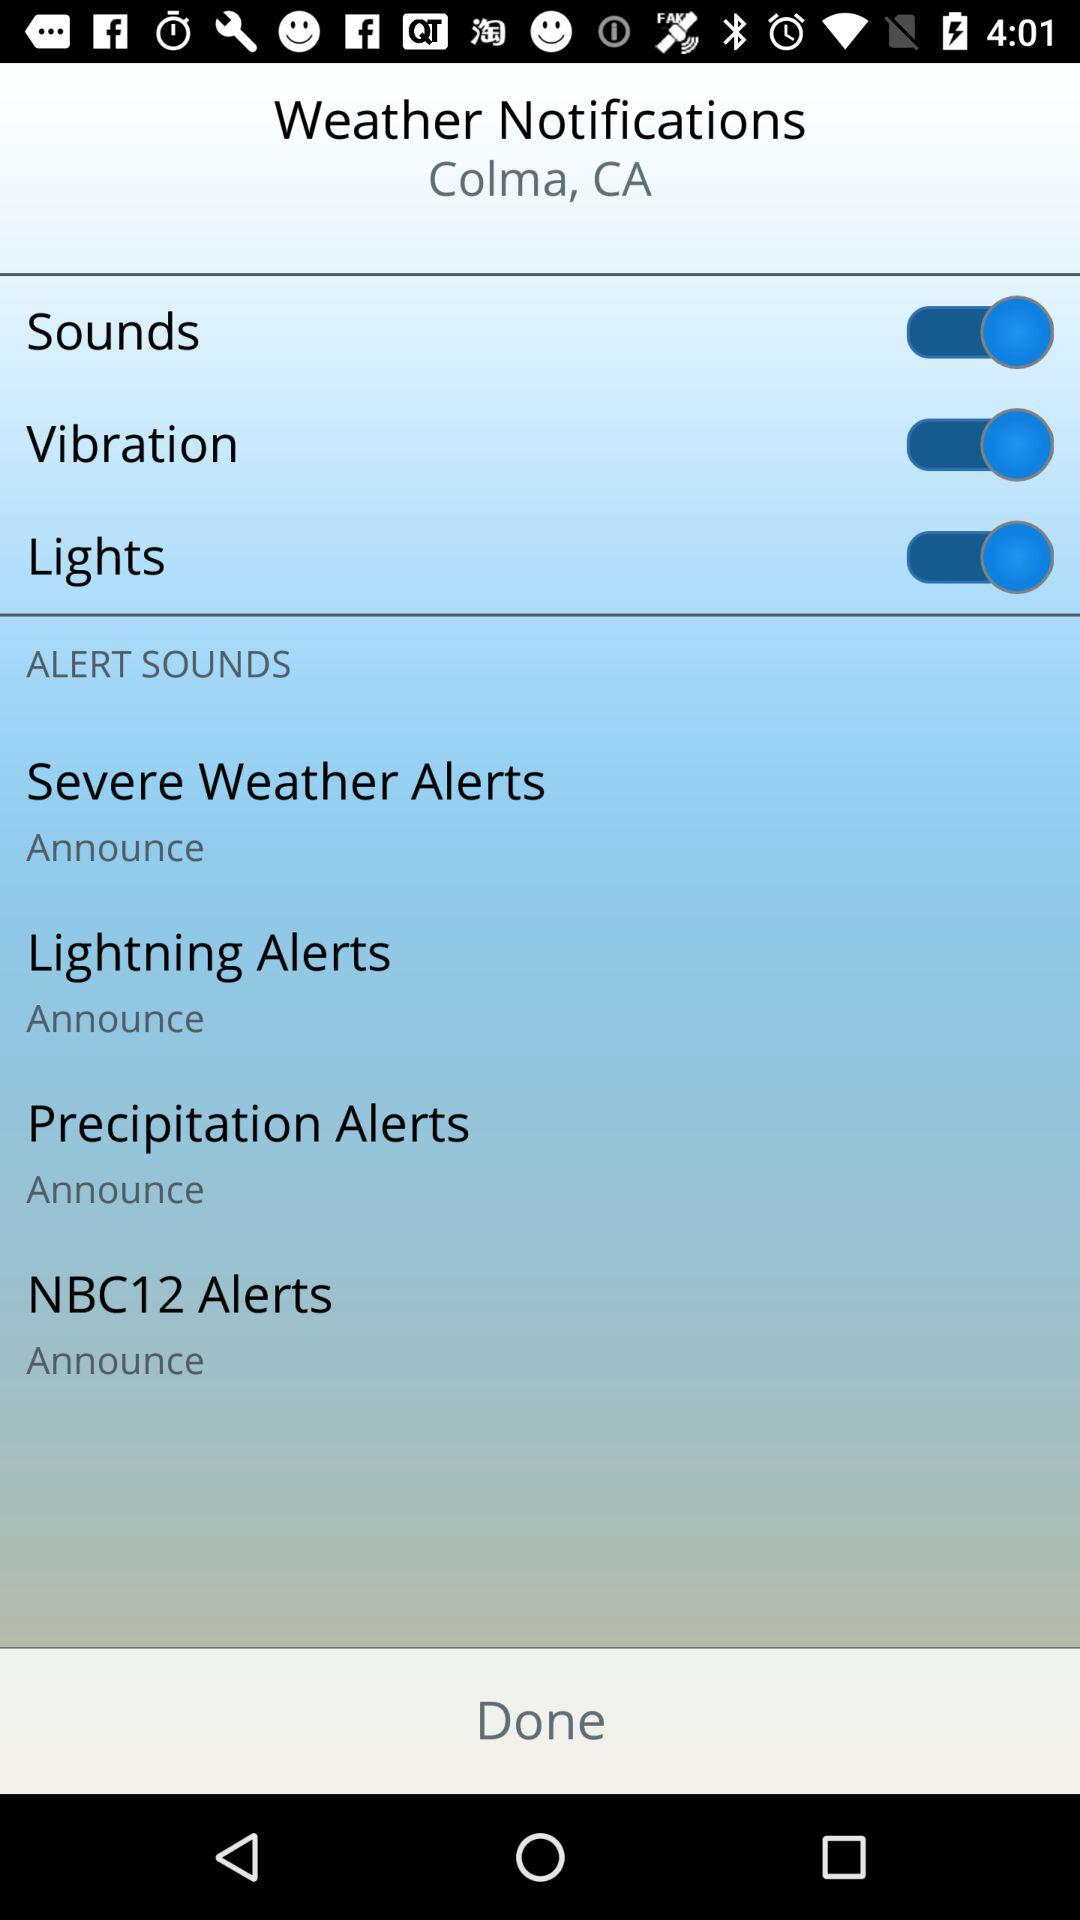What is the setting for the precipitation alerts? The setting for the precipitation alerts is "Announce". 